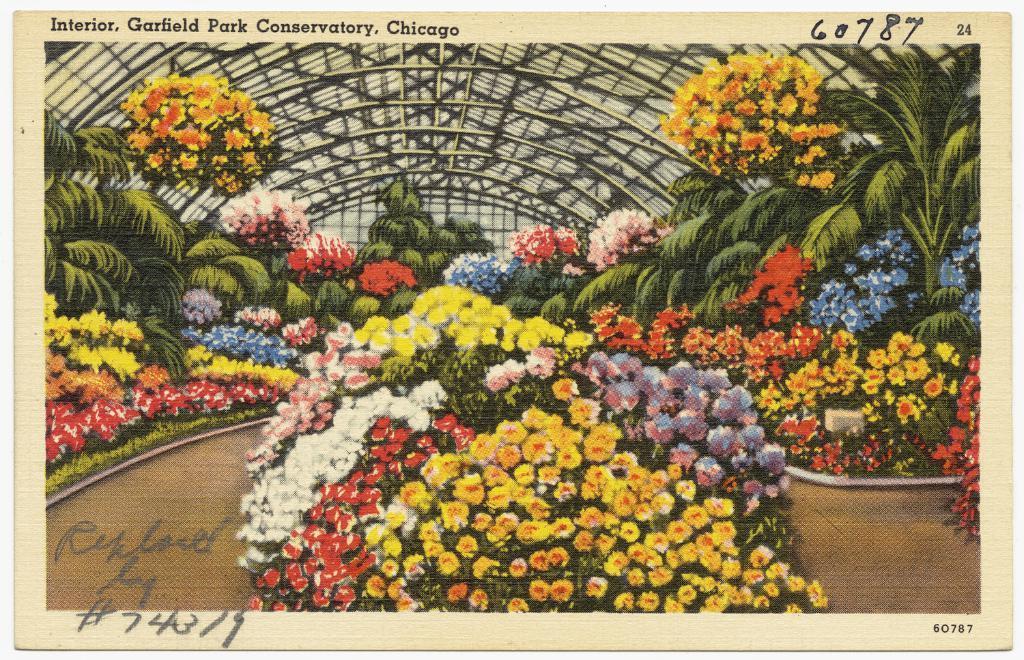Please provide a concise description of this image. In this picture we can see poster, in this poster we can see flowers, plants, grass, shed, text and numbers. 